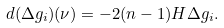<formula> <loc_0><loc_0><loc_500><loc_500>d ( \Delta g _ { i } ) ( \nu ) = - 2 ( n - 1 ) H \Delta g _ { i } .</formula> 